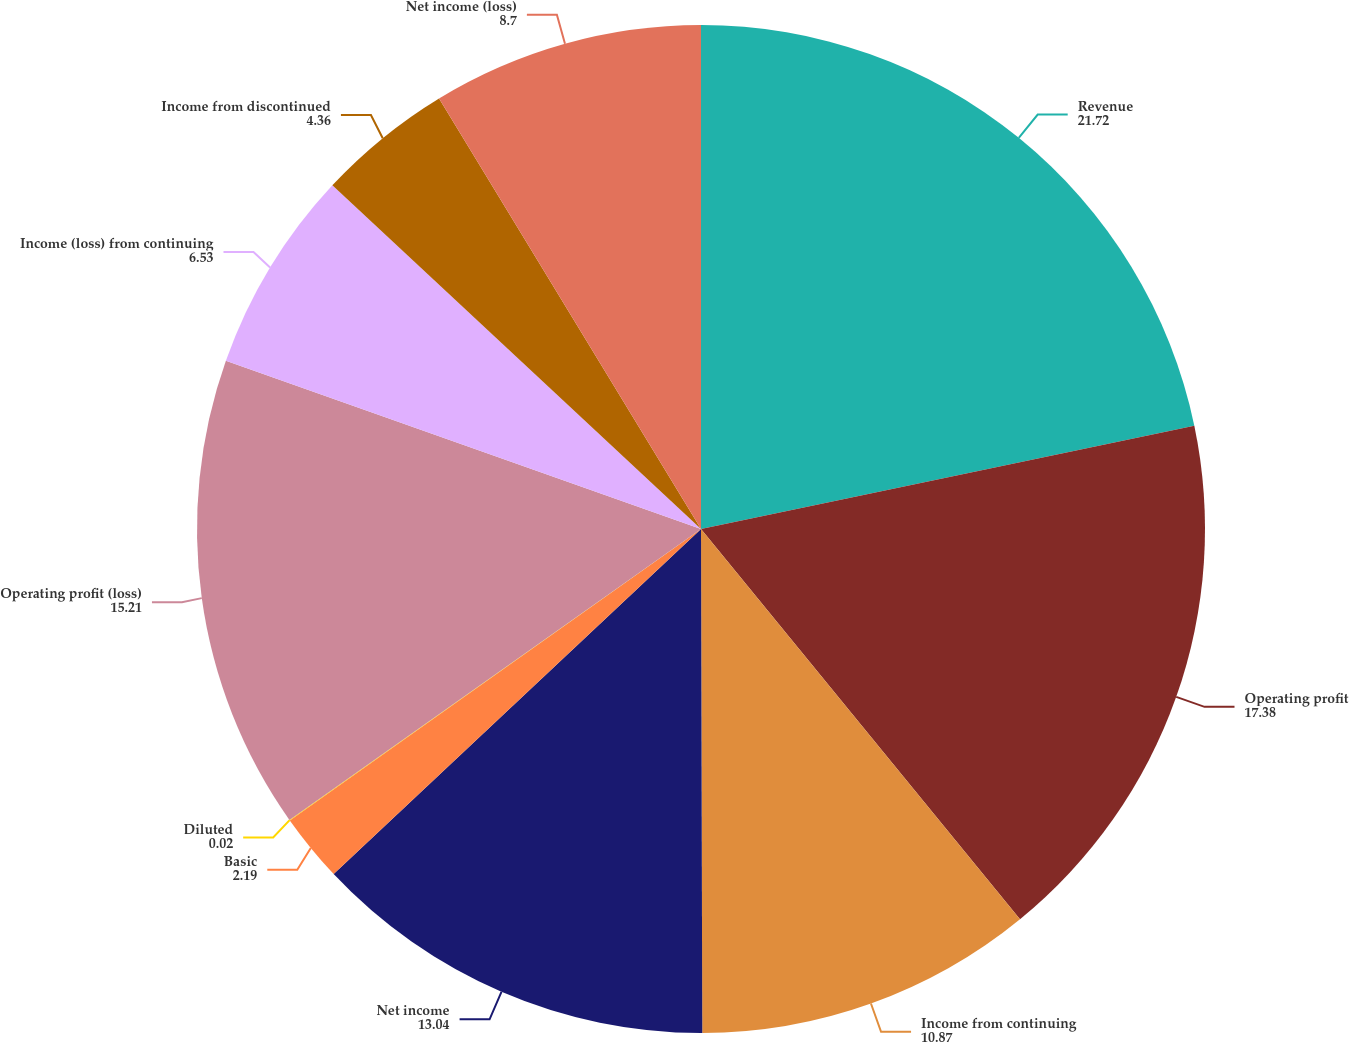Convert chart. <chart><loc_0><loc_0><loc_500><loc_500><pie_chart><fcel>Revenue<fcel>Operating profit<fcel>Income from continuing<fcel>Net income<fcel>Basic<fcel>Diluted<fcel>Operating profit (loss)<fcel>Income (loss) from continuing<fcel>Income from discontinued<fcel>Net income (loss)<nl><fcel>21.72%<fcel>17.38%<fcel>10.87%<fcel>13.04%<fcel>2.19%<fcel>0.02%<fcel>15.21%<fcel>6.53%<fcel>4.36%<fcel>8.7%<nl></chart> 